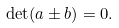<formula> <loc_0><loc_0><loc_500><loc_500>\det ( a \pm b ) = 0 .</formula> 